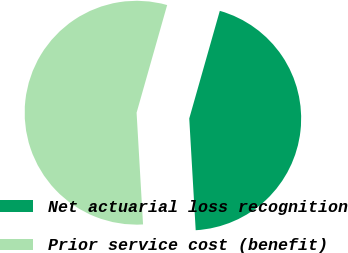Convert chart. <chart><loc_0><loc_0><loc_500><loc_500><pie_chart><fcel>Net actuarial loss recognition<fcel>Prior service cost (benefit)<nl><fcel>44.68%<fcel>55.32%<nl></chart> 